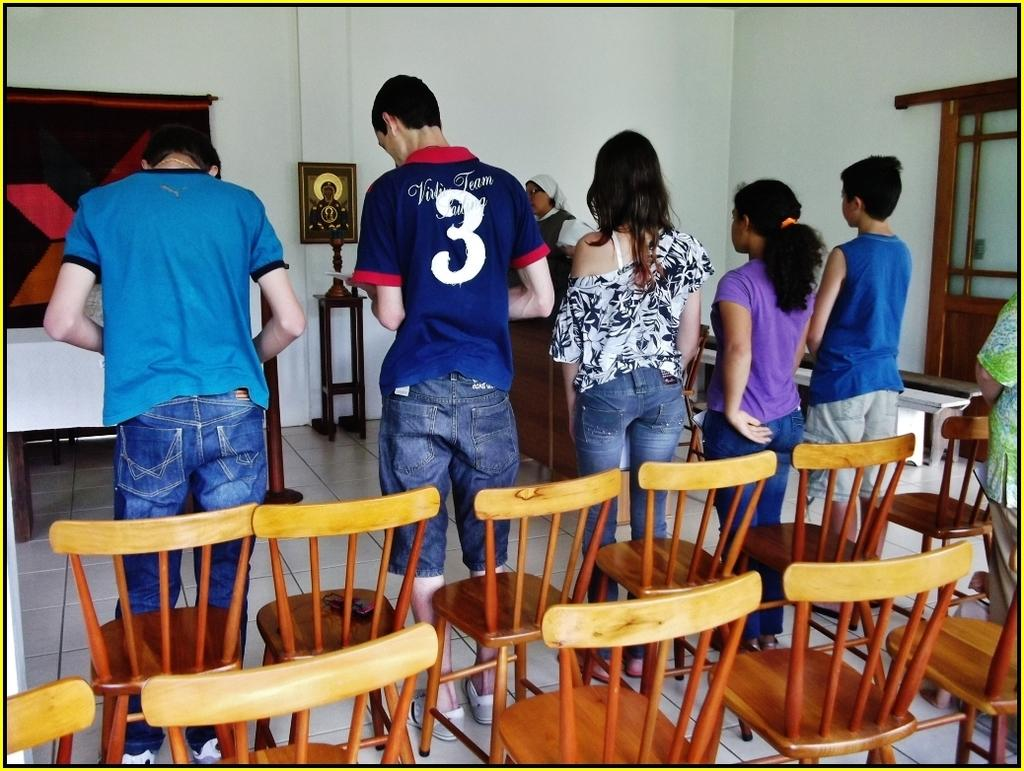What are the people in the image doing? The persons standing in the center of the image are likely waiting or gathered for a specific purpose. What objects are present in the foreground of the image? There are empty chairs in the front bottom of the image. What can be seen in the background of the image? There is a wall, a photo frame, a window, and a table in the background of the image. What type of order is being given by the servant in the image? There is no servant present in the image, and therefore no order is being given. What is being carried in the sack in the image? There is no sack present in the image, so it is not possible to determine what might be inside. 